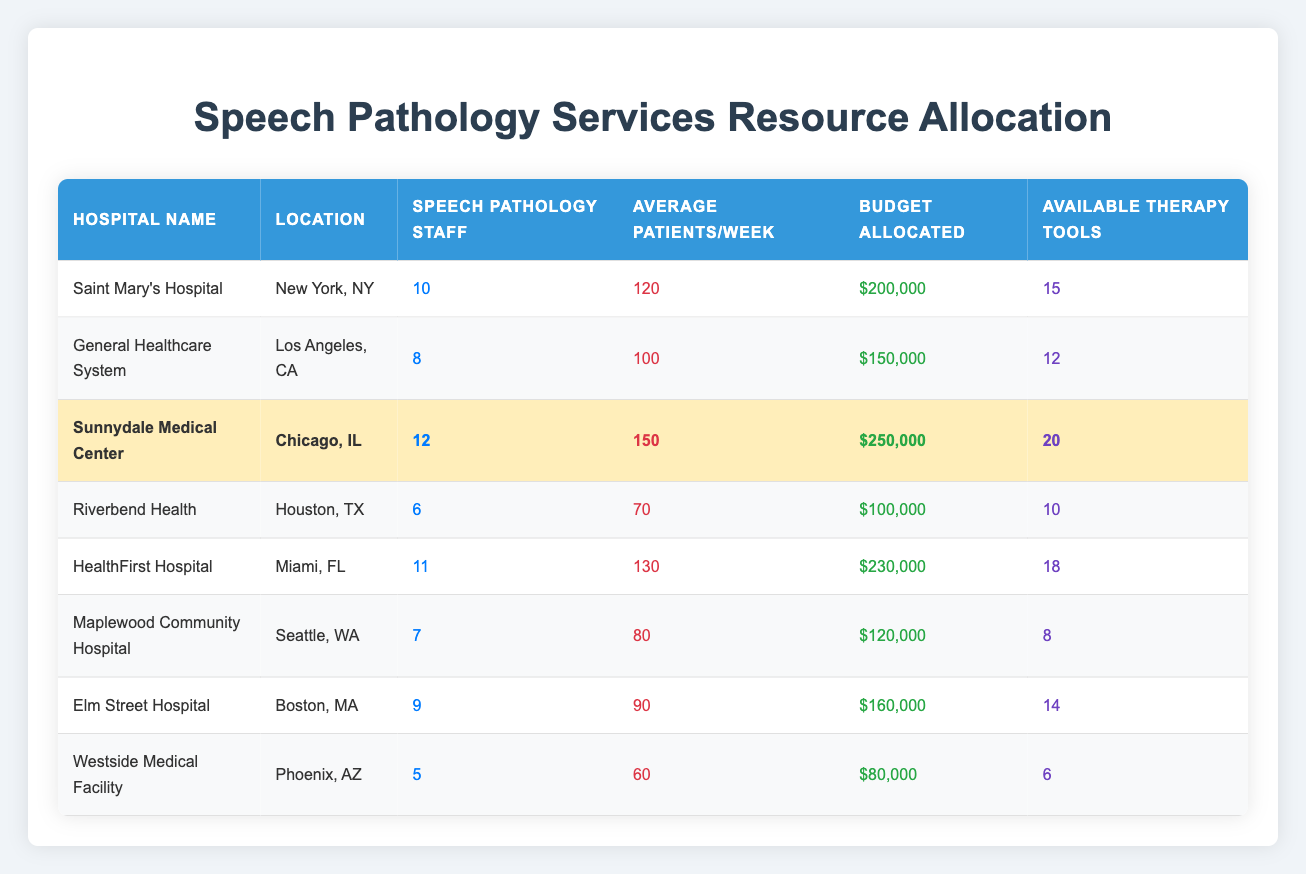What is the total number of speech pathology staff across all hospitals? To find the total, we add the number of staff from each hospital: 10 + 8 + 12 + 6 + 11 + 7 + 9 + 5 = 68.
Answer: 68 Which hospital has the highest average patients per week? From the table, Sunnydale Medical Center has the highest average patients per week at 150.
Answer: Sunnydale Medical Center What is the budget allocated for HealthFirst Hospital? The budget allocated for HealthFirst Hospital is $230,000, as shown in the table.
Answer: $230,000 How many available therapy tools does Riverbend Health have compared to Westside Medical Facility? Riverbend Health has 10 therapy tools while Westside Medical Facility has 6. Therefore, Riverbend Health has 10 - 6 = 4 more tools than Westside Medical Facility.
Answer: 4 more tools What is the average number of available therapy tools across all hospitals? First, add the number of tools: 15 + 12 + 20 + 10 + 18 + 8 + 14 + 6 = 109. There are 8 hospitals, so the average is 109 / 8 = 13.625, which can be rounded to 13.63.
Answer: 13.63 Is it true that Elm Street Hospital has more staff than General Healthcare System? Yes, Elm Street Hospital has 9 staff members while General Healthcare System has 8, so the statement is true.
Answer: Yes Which hospital has the best budget-to-patient ratio? To find the budget-to-patient ratio for each hospital, divide the budget by the average patients per week: Saint Mary's Hospital: 200,000/120 = 1666.67, General Healthcare: 150,000/100 = 1500, Sunnydale: 250,000/150 = 1666.67, Riverbend: 100,000/70 = 1428.57, HealthFirst: 230,000/130 = 1769.23, Maplewood: 120,000/80 = 1500, Elm Street: 160,000/90 = 1777.78, Westside: 80,000/60 = 1333.33. HealthFirst Hospital has the best budget-to-patient ratio at approximately 1769.23.
Answer: HealthFirst Hospital What is the difference in the budget allocated for Sunnydale Medical Center and Riverbend Health? The budget for Sunnydale Medical Center is $250,000 and for Riverbend Health is $100,000. The difference is $250,000 - $100,000 = $150,000.
Answer: $150,000 Which hospital has the least number of speech pathology staff? By checking the table, Westside Medical Facility has the least staff with only 5 members.
Answer: Westside Medical Facility What is the median budget allocated for speech services across these hospitals? The budgets sorted in order are: 80,000; 100,000; 120,000; 150,000; 160,000; 200,000; 230,000; 250,000. There are 8 hospitals (even count), so the median is the average of the 4th and 5th values: (150,000 + 160,000)/2 = 155,000.
Answer: $155,000 